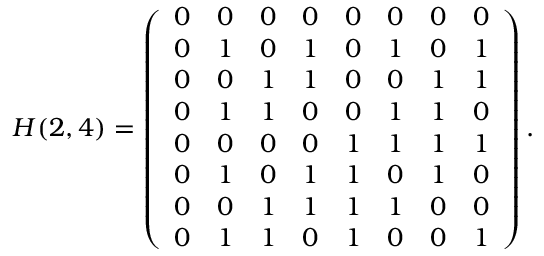Convert formula to latex. <formula><loc_0><loc_0><loc_500><loc_500>H ( 2 , 4 ) = \left ( \begin{array} { c c c c c c c c } { 0 } & { 0 } & { 0 } & { 0 } & { 0 } & { 0 } & { 0 } & { 0 } \\ { 0 } & { 1 } & { 0 } & { 1 } & { 0 } & { 1 } & { 0 } & { 1 } \\ { 0 } & { 0 } & { 1 } & { 1 } & { 0 } & { 0 } & { 1 } & { 1 } \\ { 0 } & { 1 } & { 1 } & { 0 } & { 0 } & { 1 } & { 1 } & { 0 } \\ { 0 } & { 0 } & { 0 } & { 0 } & { 1 } & { 1 } & { 1 } & { 1 } \\ { 0 } & { 1 } & { 0 } & { 1 } & { 1 } & { 0 } & { 1 } & { 0 } \\ { 0 } & { 0 } & { 1 } & { 1 } & { 1 } & { 1 } & { 0 } & { 0 } \\ { 0 } & { 1 } & { 1 } & { 0 } & { 1 } & { 0 } & { 0 } & { 1 } \end{array} \right ) .</formula> 